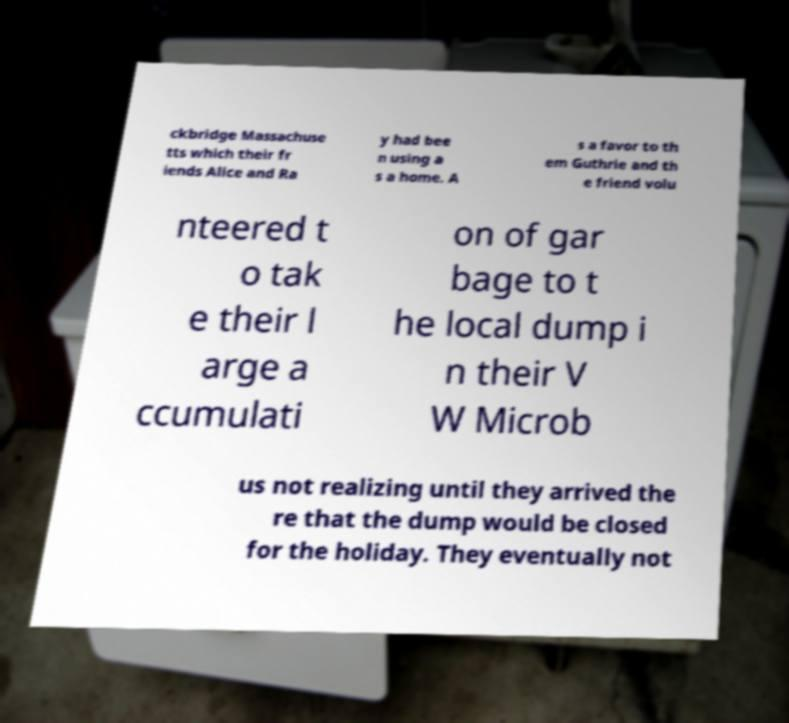Can you read and provide the text displayed in the image?This photo seems to have some interesting text. Can you extract and type it out for me? ckbridge Massachuse tts which their fr iends Alice and Ra y had bee n using a s a home. A s a favor to th em Guthrie and th e friend volu nteered t o tak e their l arge a ccumulati on of gar bage to t he local dump i n their V W Microb us not realizing until they arrived the re that the dump would be closed for the holiday. They eventually not 